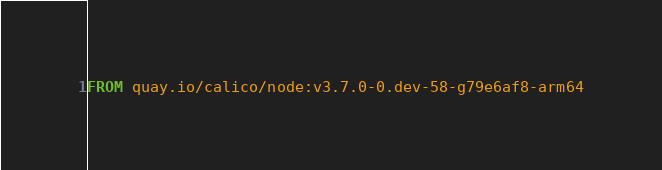<code> <loc_0><loc_0><loc_500><loc_500><_Dockerfile_>FROM quay.io/calico/node:v3.7.0-0.dev-58-g79e6af8-arm64
</code> 